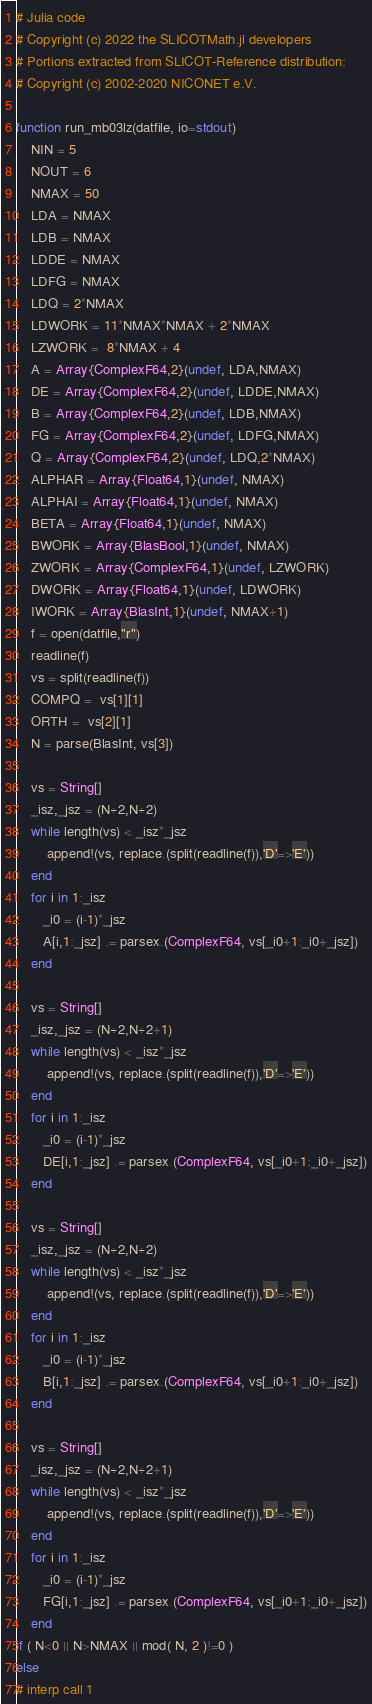Convert code to text. <code><loc_0><loc_0><loc_500><loc_500><_Julia_># Julia code
# Copyright (c) 2022 the SLICOTMath.jl developers
# Portions extracted from SLICOT-Reference distribution:
# Copyright (c) 2002-2020 NICONET e.V.

function run_mb03lz(datfile, io=stdout)
    NIN = 5
    NOUT = 6
    NMAX = 50
    LDA = NMAX
    LDB = NMAX
    LDDE = NMAX
    LDFG = NMAX
    LDQ = 2*NMAX
    LDWORK = 11*NMAX*NMAX + 2*NMAX
    LZWORK =  8*NMAX + 4
    A = Array{ComplexF64,2}(undef, LDA,NMAX)
    DE = Array{ComplexF64,2}(undef, LDDE,NMAX)
    B = Array{ComplexF64,2}(undef, LDB,NMAX)
    FG = Array{ComplexF64,2}(undef, LDFG,NMAX)
    Q = Array{ComplexF64,2}(undef, LDQ,2*NMAX)
    ALPHAR = Array{Float64,1}(undef, NMAX)
    ALPHAI = Array{Float64,1}(undef, NMAX)
    BETA = Array{Float64,1}(undef, NMAX)
    BWORK = Array{BlasBool,1}(undef, NMAX)
    ZWORK = Array{ComplexF64,1}(undef, LZWORK)
    DWORK = Array{Float64,1}(undef, LDWORK)
    IWORK = Array{BlasInt,1}(undef, NMAX+1)
    f = open(datfile,"r")
    readline(f)
    vs = split(readline(f))
    COMPQ =  vs[1][1]
    ORTH =  vs[2][1]
    N = parse(BlasInt, vs[3])

    vs = String[]
    _isz,_jsz = (N÷2,N÷2)
    while length(vs) < _isz*_jsz
        append!(vs, replace.(split(readline(f)),'D'=>'E'))
    end
    for i in 1:_isz
       _i0 = (i-1)*_jsz
       A[i,1:_jsz] .= parsex.(ComplexF64, vs[_i0+1:_i0+_jsz])
    end

    vs = String[]
    _isz,_jsz = (N÷2,N÷2+1)
    while length(vs) < _isz*_jsz
        append!(vs, replace.(split(readline(f)),'D'=>'E'))
    end
    for i in 1:_isz
       _i0 = (i-1)*_jsz
       DE[i,1:_jsz] .= parsex.(ComplexF64, vs[_i0+1:_i0+_jsz])
    end

    vs = String[]
    _isz,_jsz = (N÷2,N÷2)
    while length(vs) < _isz*_jsz
        append!(vs, replace.(split(readline(f)),'D'=>'E'))
    end
    for i in 1:_isz
       _i0 = (i-1)*_jsz
       B[i,1:_jsz] .= parsex.(ComplexF64, vs[_i0+1:_i0+_jsz])
    end

    vs = String[]
    _isz,_jsz = (N÷2,N÷2+1)
    while length(vs) < _isz*_jsz
        append!(vs, replace.(split(readline(f)),'D'=>'E'))
    end
    for i in 1:_isz
       _i0 = (i-1)*_jsz
       FG[i,1:_jsz] .= parsex.(ComplexF64, vs[_i0+1:_i0+_jsz])
    end
if ( N<0 || N>NMAX || mod( N, 2 )!=0 )
else
# interp call 1
</code> 